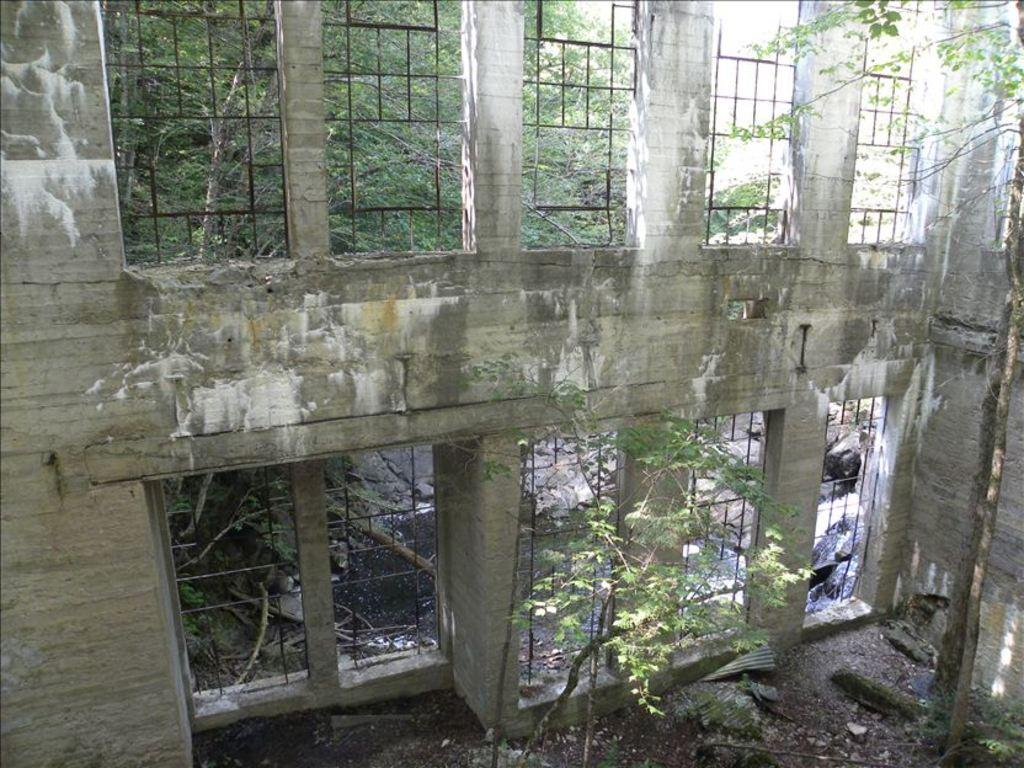What is the main feature of the wall in the image? The wall in the image has iron rods. What can be seen in the background of the image? There are trees in the background of the image. Is there an umbrella being used by the woman in the image? There is no woman or umbrella present in the image. How many arrows are in the quiver of the person in the image? There is no person or quiver present in the image. 